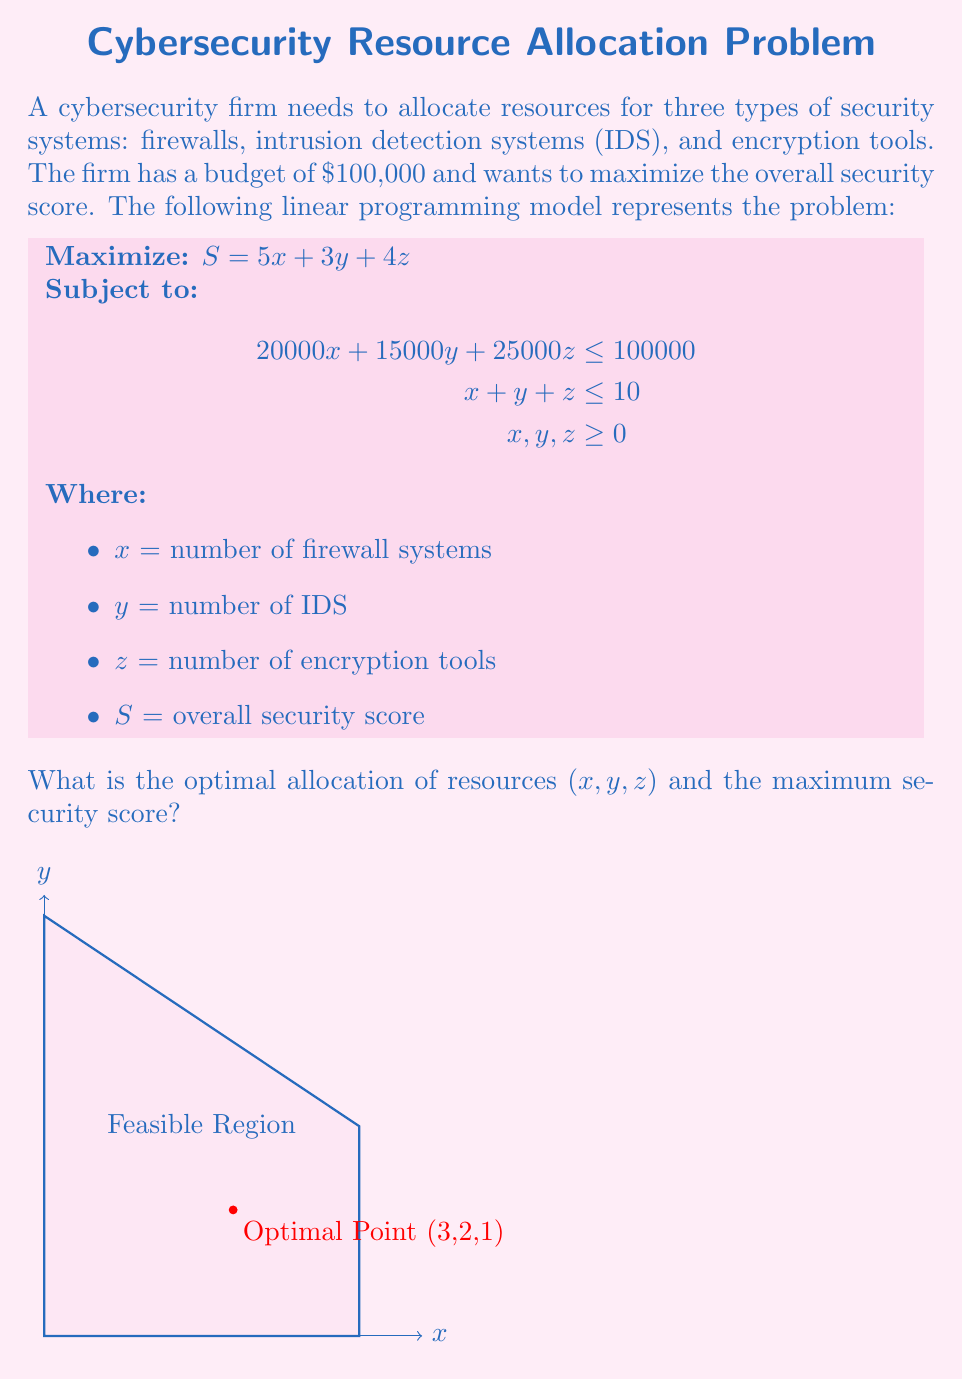Could you help me with this problem? To solve this linear programming problem, we'll use the simplex method:

1. Convert inequality constraints to equality by adding slack variables:
   $20000x + 15000y + 25000z + s_1 = 100000$
   $x + y + z + s_2 = 10$

2. Set up the initial simplex tableau:
   $$
   \begin{array}{c|cccccc|c}
   & x & y & z & s_1 & s_2 & S & RHS \\
   \hline
   s_1 & 20000 & 15000 & 25000 & 1 & 0 & 0 & 100000 \\
   s_2 & 1 & 1 & 1 & 0 & 1 & 0 & 10 \\
   \hline
   -S & -5 & -3 & -4 & 0 & 0 & 1 & 0
   \end{array}
   $$

3. Identify the pivot column (most negative in bottom row): x (-5)

4. Calculate ratios and identify pivot row:
   $100000 / 20000 = 5$
   $10 / 1 = 10$
   Pivot row: first row

5. Perform row operations to get the new tableau:
   $$
   \begin{array}{c|cccccc|c}
   & x & y & z & s_1 & s_2 & S & RHS \\
   \hline
   x & 1 & 0.75 & 1.25 & 0.00005 & 0 & 0 & 5 \\
   s_2 & 0 & 0.25 & -0.25 & -0.00005 & 1 & 0 & 5 \\
   \hline
   -S & 0 & -0.75 & 2.25 & 0.00025 & 0 & 1 & 25
   \end{array}
   $$

6. Repeat steps 3-5 until no negative values remain in the bottom row.

7. Final tableau:
   $$
   \begin{array}{c|cccccc|c}
   & x & y & z & s_1 & s_2 & S & RHS \\
   \hline
   x & 1 & 0 & 0 & 0.00015 & -1 & 0 & 3 \\
   y & 0 & 1 & 0 & -0.00005 & 1 & 0 & 2 \\
   z & 0 & 0 & 1 & -0.00005 & 1 & 0 & 1 \\
   \hline
   -S & 0 & 0 & 0 & 0.00035 & -2 & 1 & 28
   \end{array}
   $$

8. Read the optimal solution:
   $x = 3$ (firewalls)
   $y = 2$ (IDS)
   $z = 1$ (encryption tools)
   Maximum security score $S = 28$

9. Verify the solution:
   Budget constraint: $20000(3) + 15000(2) + 25000(1) = 95000 \leq 100000$
   System constraint: $3 + 2 + 1 = 6 \leq 10$
   Security score: $5(3) + 3(2) + 4(1) = 28$
Answer: Optimal allocation: (3, 2, 1); Maximum security score: 28 